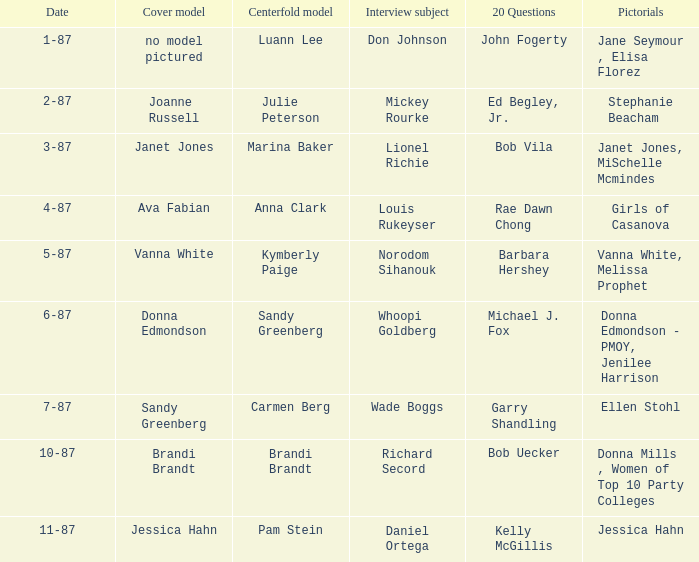Who was the on the cover when Bob Vila did the 20 Questions? Janet Jones. 